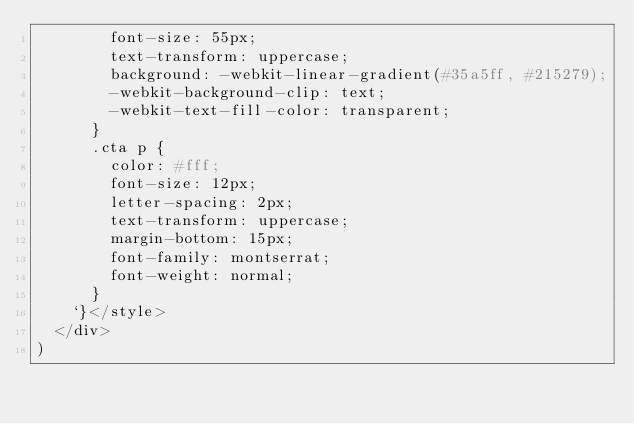Convert code to text. <code><loc_0><loc_0><loc_500><loc_500><_JavaScript_>        font-size: 55px;
        text-transform: uppercase;
        background: -webkit-linear-gradient(#35a5ff, #215279);
        -webkit-background-clip: text;
        -webkit-text-fill-color: transparent;
      }
      .cta p {
        color: #fff;
        font-size: 12px;
        letter-spacing: 2px;
        text-transform: uppercase;
        margin-bottom: 15px;
        font-family: montserrat;
        font-weight: normal;
      }
    `}</style>
  </div>
)
</code> 